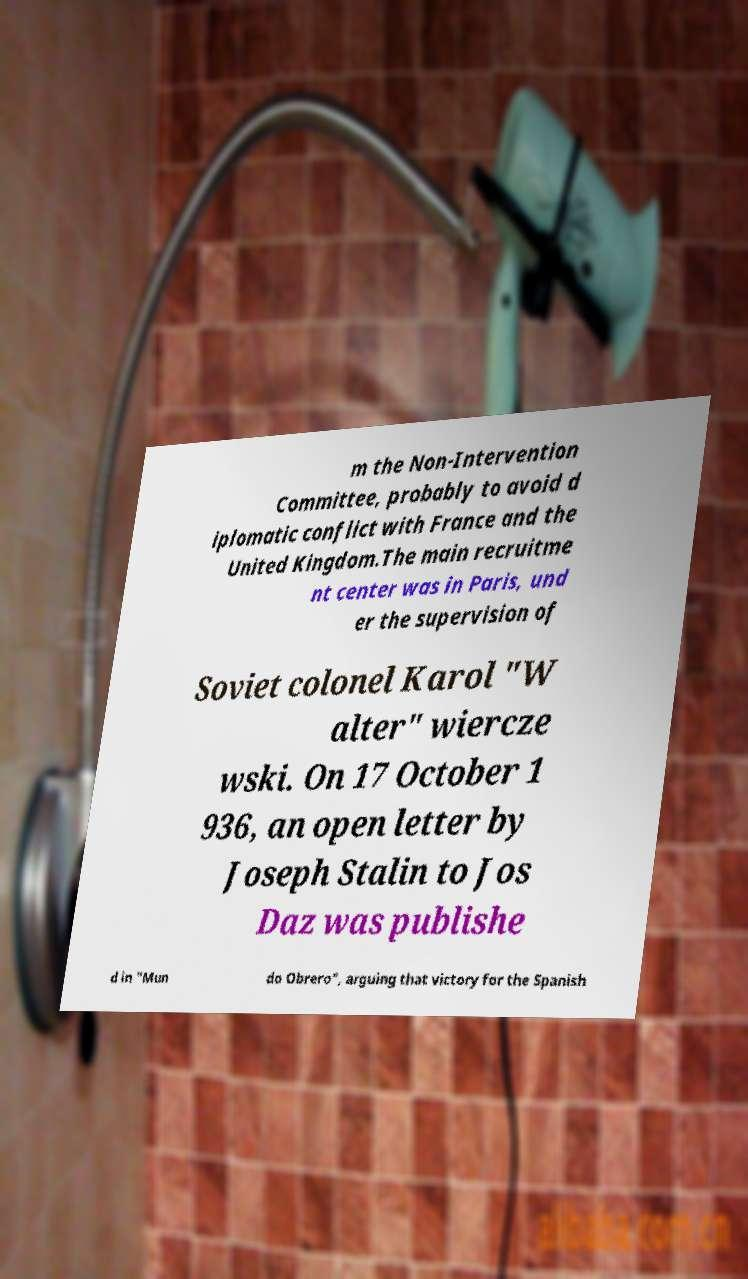Could you extract and type out the text from this image? m the Non-Intervention Committee, probably to avoid d iplomatic conflict with France and the United Kingdom.The main recruitme nt center was in Paris, und er the supervision of Soviet colonel Karol "W alter" wiercze wski. On 17 October 1 936, an open letter by Joseph Stalin to Jos Daz was publishe d in "Mun do Obrero", arguing that victory for the Spanish 